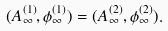<formula> <loc_0><loc_0><loc_500><loc_500>( A ^ { ( 1 ) } _ { \infty } , \phi ^ { ( 1 ) } _ { \infty } ) = ( A ^ { ( 2 ) } _ { \infty } , \phi ^ { ( 2 ) } _ { \infty } ) .</formula> 